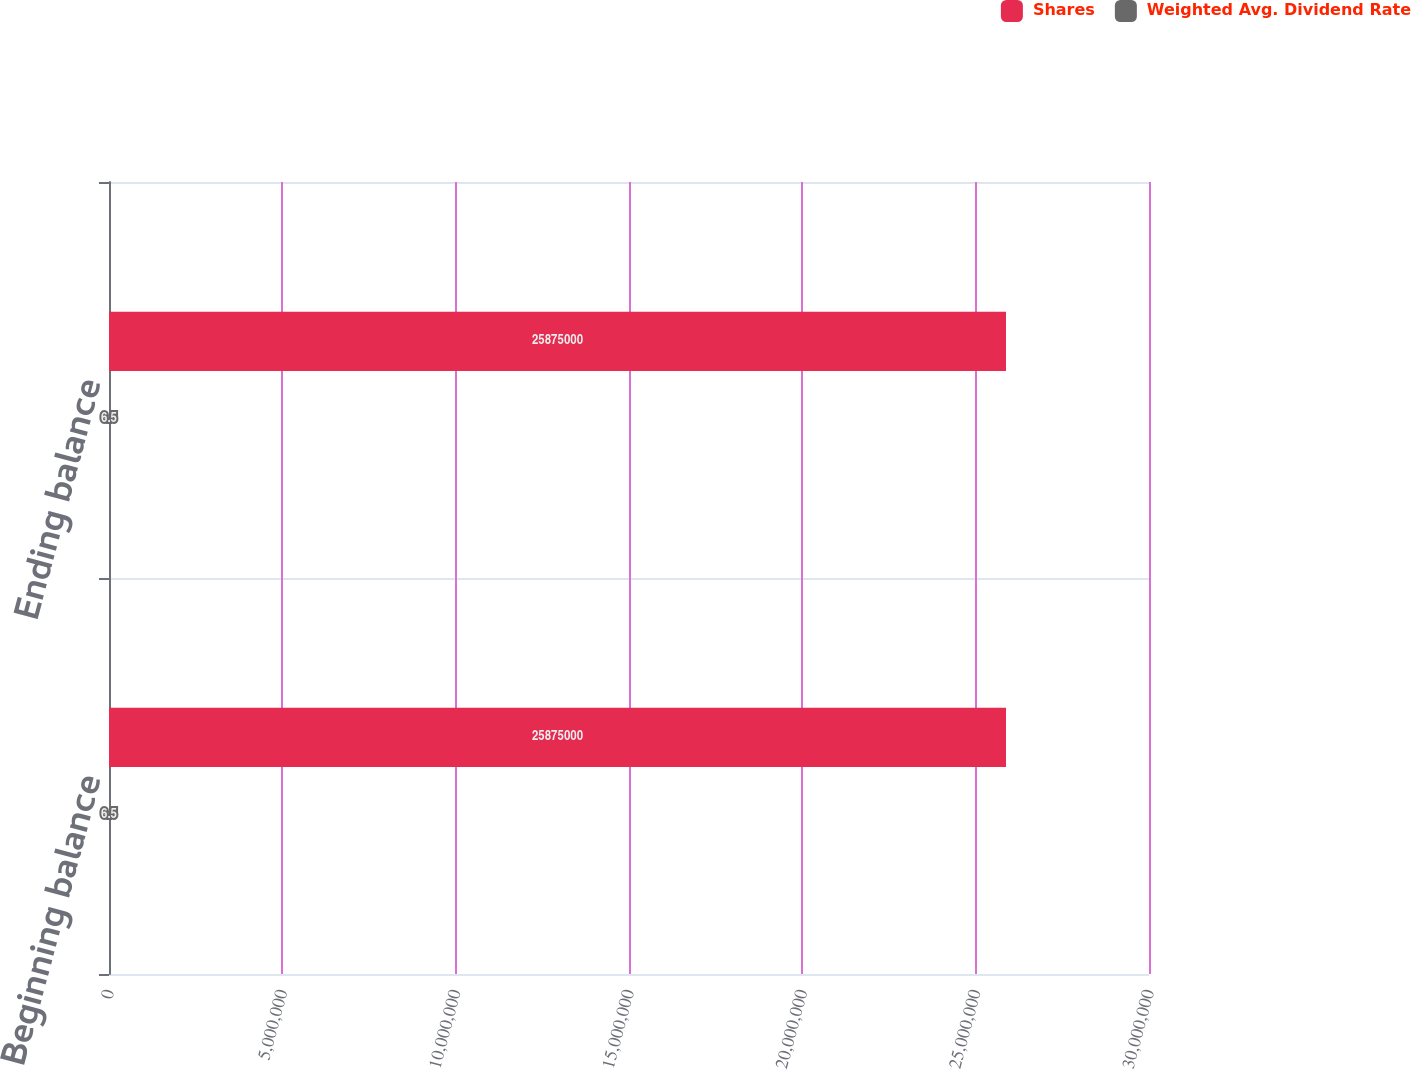Convert chart to OTSL. <chart><loc_0><loc_0><loc_500><loc_500><stacked_bar_chart><ecel><fcel>Beginning balance<fcel>Ending balance<nl><fcel>Shares<fcel>2.5875e+07<fcel>2.5875e+07<nl><fcel>Weighted Avg. Dividend Rate<fcel>6.5<fcel>6.5<nl></chart> 